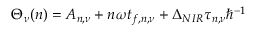<formula> <loc_0><loc_0><loc_500><loc_500>\Theta _ { \nu } ( n ) = A _ { n , \nu } + n \omega t _ { f , n , \nu } + \Delta _ { N I R } \tau _ { n , \nu } \hbar { ^ } { - 1 }</formula> 